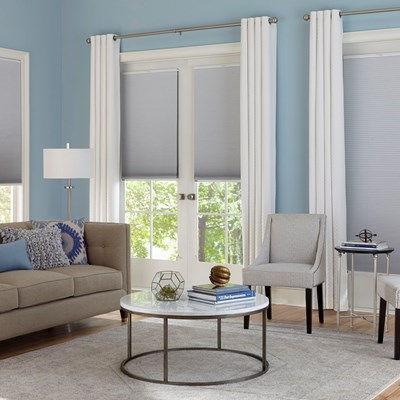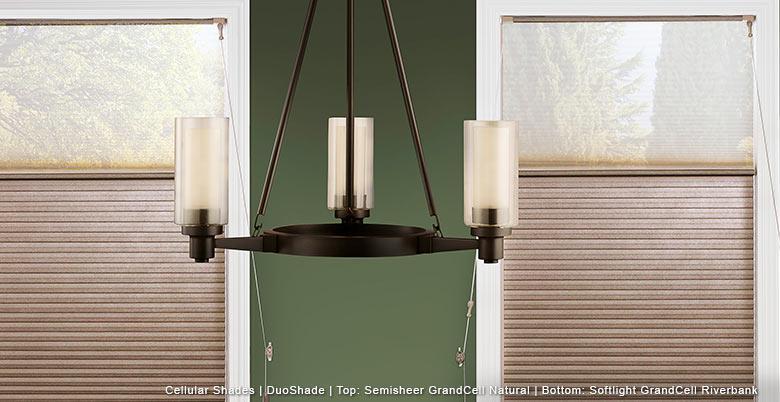The first image is the image on the left, the second image is the image on the right. Assess this claim about the two images: "There is a total of two blinds.". Correct or not? Answer yes or no. No. The first image is the image on the left, the second image is the image on the right. Analyze the images presented: Is the assertion "There is exactly one window in the right image." valid? Answer yes or no. No. 